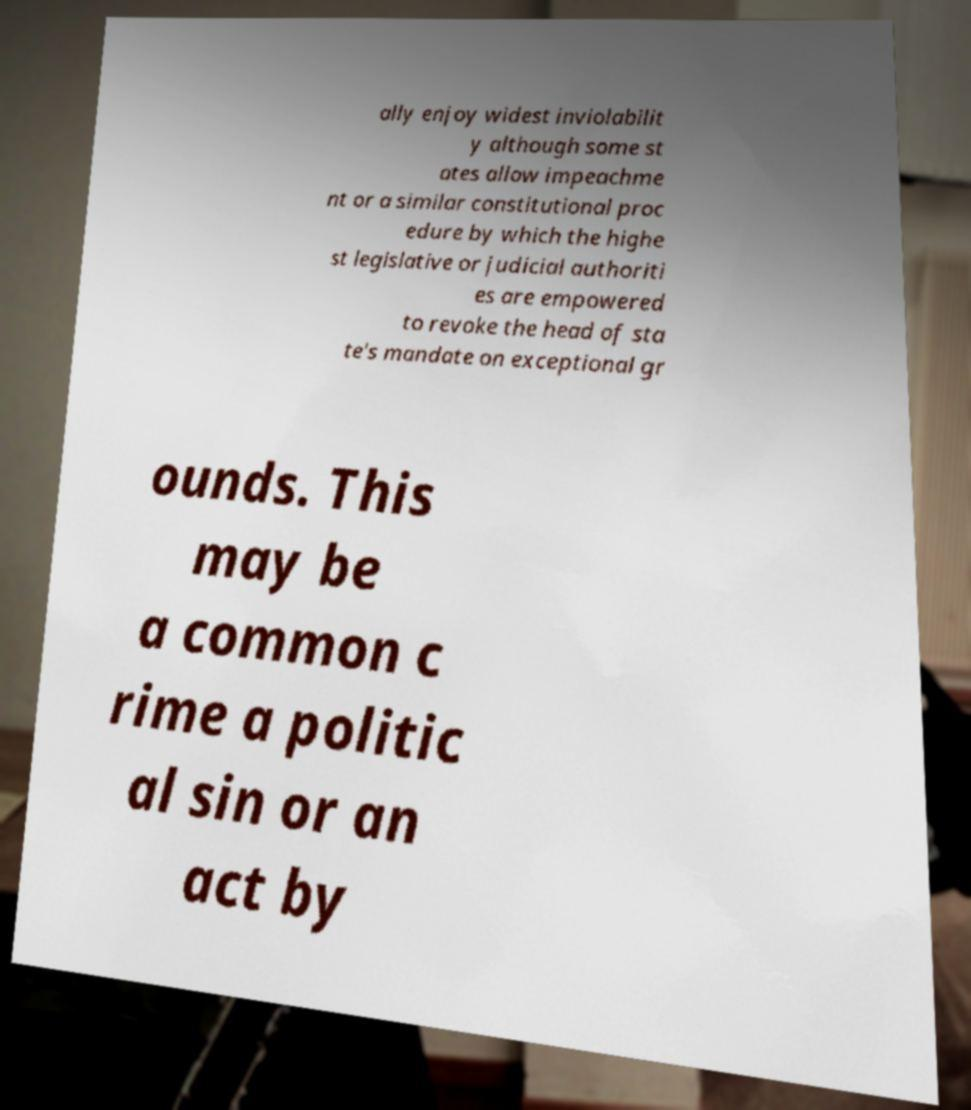For documentation purposes, I need the text within this image transcribed. Could you provide that? ally enjoy widest inviolabilit y although some st ates allow impeachme nt or a similar constitutional proc edure by which the highe st legislative or judicial authoriti es are empowered to revoke the head of sta te's mandate on exceptional gr ounds. This may be a common c rime a politic al sin or an act by 